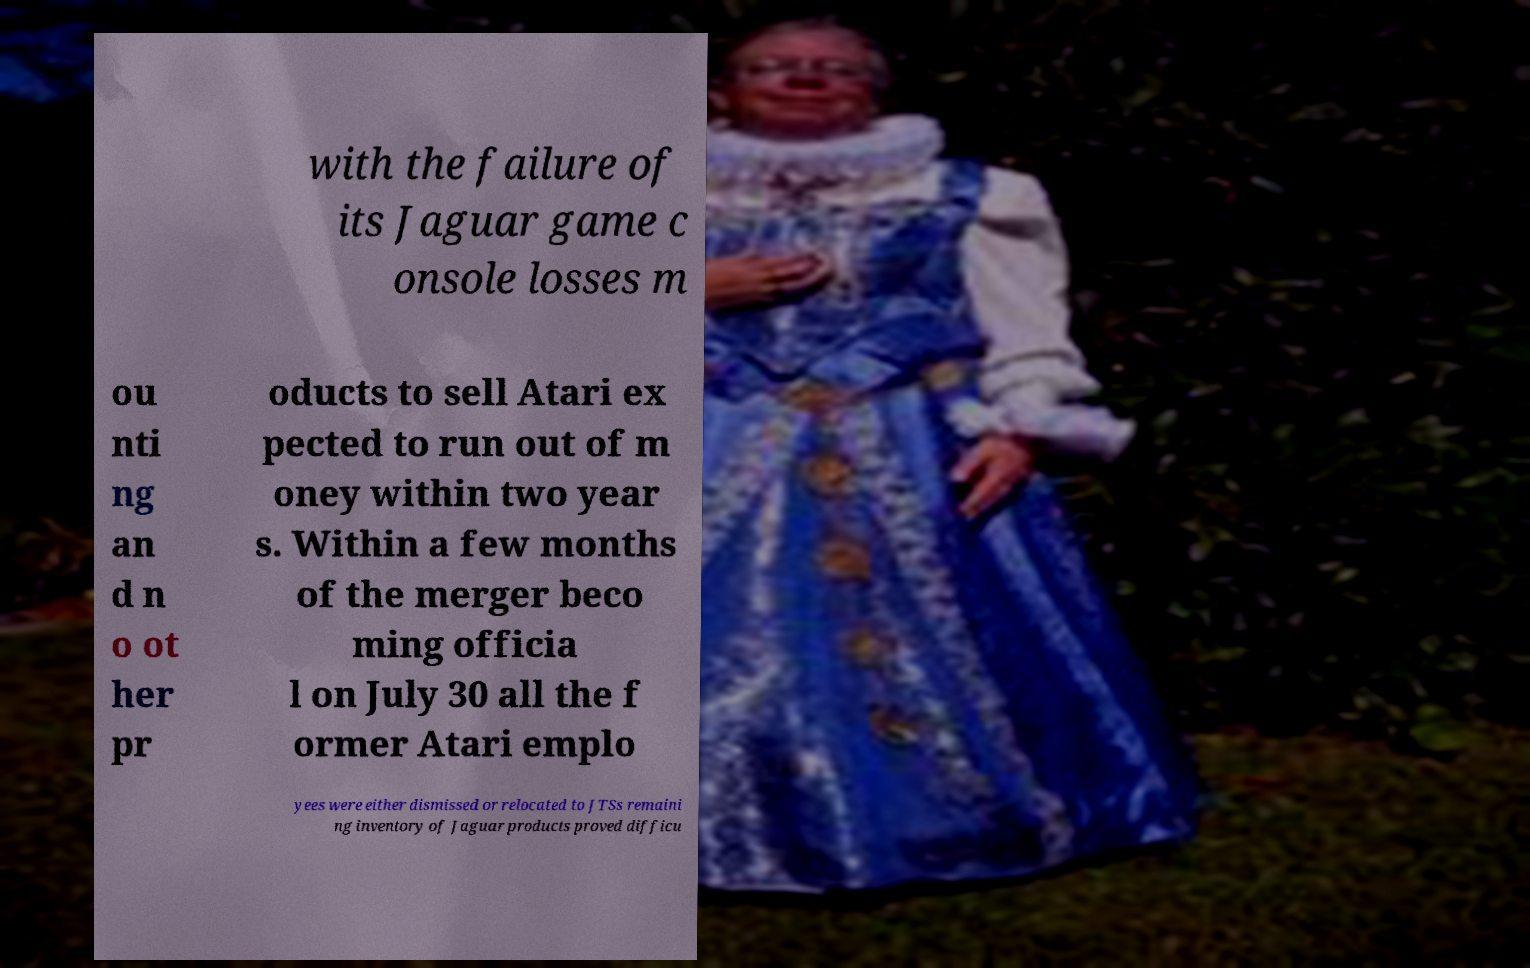Please read and relay the text visible in this image. What does it say? with the failure of its Jaguar game c onsole losses m ou nti ng an d n o ot her pr oducts to sell Atari ex pected to run out of m oney within two year s. Within a few months of the merger beco ming officia l on July 30 all the f ormer Atari emplo yees were either dismissed or relocated to JTSs remaini ng inventory of Jaguar products proved difficu 